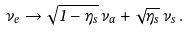<formula> <loc_0><loc_0><loc_500><loc_500>\nu _ { e } \to \sqrt { 1 - \eta _ { s } } \, \nu _ { a } + \sqrt { \eta _ { s } } \, \nu _ { s } \, .</formula> 